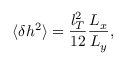Convert formula to latex. <formula><loc_0><loc_0><loc_500><loc_500>\langle \delta h ^ { 2 } \rangle = \frac { l _ { T } ^ { 2 } } { 1 2 } \frac { L _ { x } } { L _ { y } } ,</formula> 